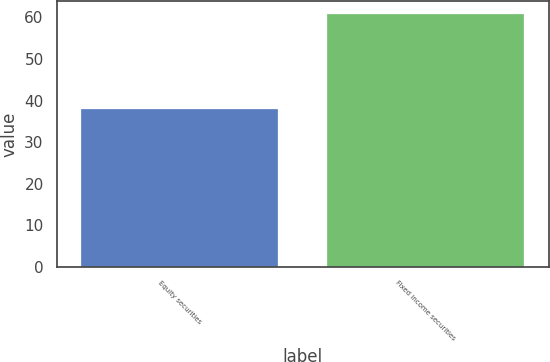Convert chart to OTSL. <chart><loc_0><loc_0><loc_500><loc_500><bar_chart><fcel>Equity securities<fcel>Fixed income securities<nl><fcel>38<fcel>60.9<nl></chart> 